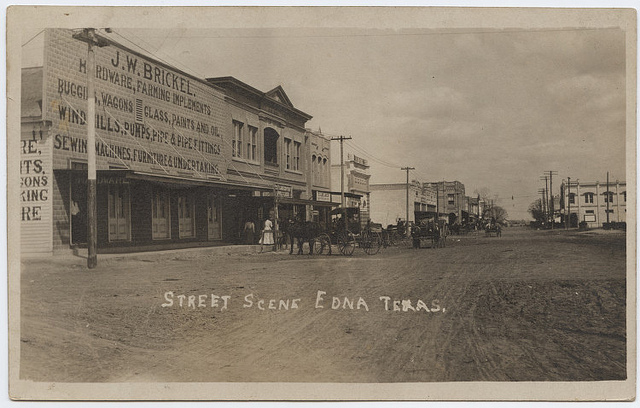Please extract the text content from this image. STREET SCENE E DNA TEKAS RE KING ONS TS E & SEWINMACHINES PIPS PUMPS ILLS WIND BUGGI OF AND PAINTS GLASS WAGONS K RDWARE, IMPLEMENTS FARMING BRICKEL W J 